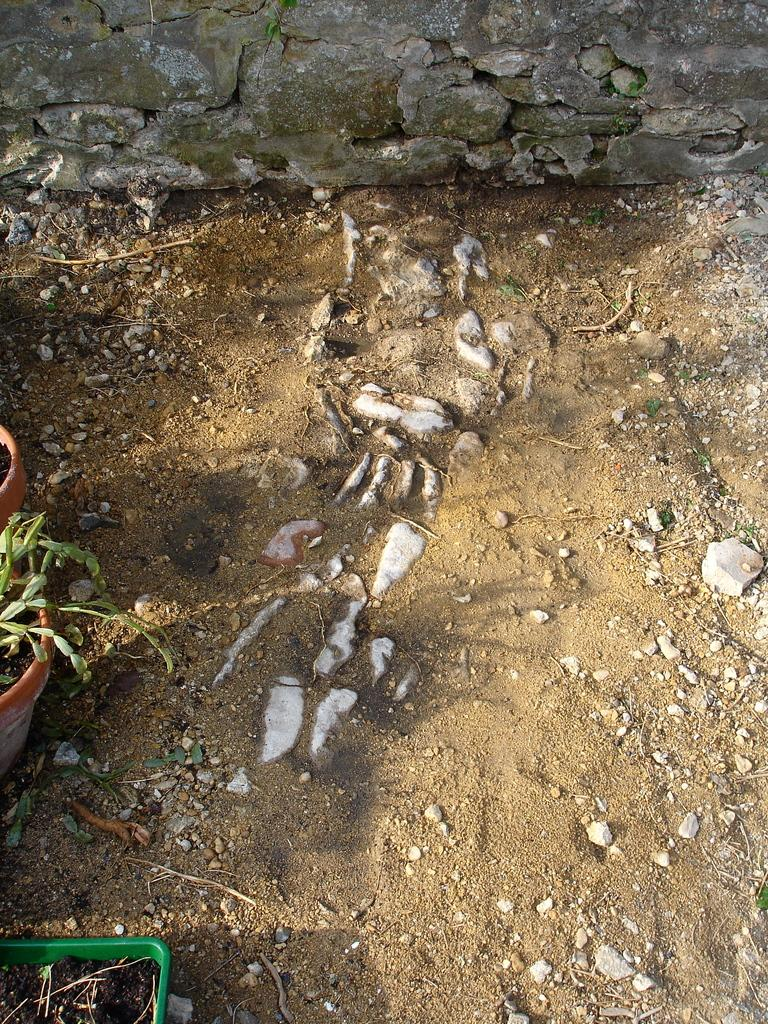What objects are located on the left side of the image? There are plant pots on the left side of the image. What can be seen on the floor in the image? There are stones on the floor. What type of structure is visible at the top side of the image? There appears to be a wall at the top side of the image. Can you tell me how many squirrels are climbing on the wall in the image? There are no squirrels present in the image; it only shows plant pots, stones, and a wall. What type of error is visible on the wall in the image? There is no error visible on the wall in the image. 